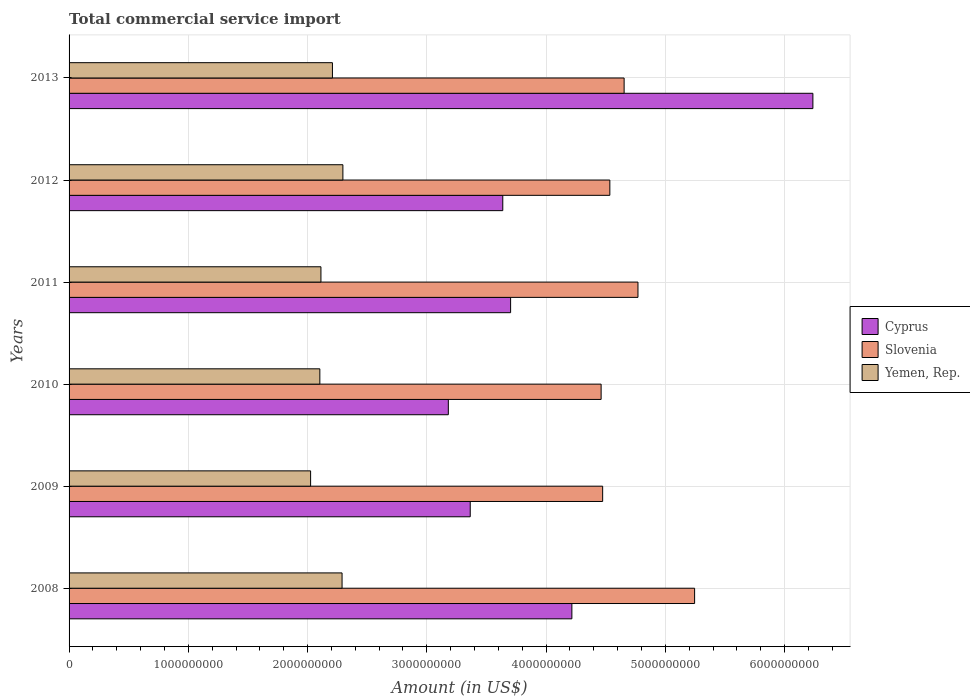How many groups of bars are there?
Give a very brief answer. 6. Are the number of bars per tick equal to the number of legend labels?
Offer a very short reply. Yes. Are the number of bars on each tick of the Y-axis equal?
Keep it short and to the point. Yes. How many bars are there on the 1st tick from the top?
Give a very brief answer. 3. How many bars are there on the 4th tick from the bottom?
Your response must be concise. 3. In how many cases, is the number of bars for a given year not equal to the number of legend labels?
Offer a terse response. 0. What is the total commercial service import in Slovenia in 2012?
Your answer should be compact. 4.53e+09. Across all years, what is the maximum total commercial service import in Cyprus?
Give a very brief answer. 6.24e+09. Across all years, what is the minimum total commercial service import in Slovenia?
Provide a short and direct response. 4.46e+09. In which year was the total commercial service import in Yemen, Rep. minimum?
Provide a short and direct response. 2009. What is the total total commercial service import in Yemen, Rep. in the graph?
Offer a terse response. 1.30e+1. What is the difference between the total commercial service import in Yemen, Rep. in 2010 and that in 2011?
Keep it short and to the point. -9.16e+06. What is the difference between the total commercial service import in Cyprus in 2009 and the total commercial service import in Slovenia in 2013?
Provide a succinct answer. -1.29e+09. What is the average total commercial service import in Cyprus per year?
Ensure brevity in your answer.  4.06e+09. In the year 2012, what is the difference between the total commercial service import in Cyprus and total commercial service import in Slovenia?
Ensure brevity in your answer.  -8.98e+08. What is the ratio of the total commercial service import in Slovenia in 2008 to that in 2010?
Offer a very short reply. 1.18. Is the total commercial service import in Slovenia in 2010 less than that in 2013?
Keep it short and to the point. Yes. Is the difference between the total commercial service import in Cyprus in 2011 and 2012 greater than the difference between the total commercial service import in Slovenia in 2011 and 2012?
Your response must be concise. No. What is the difference between the highest and the second highest total commercial service import in Slovenia?
Your answer should be very brief. 4.75e+08. What is the difference between the highest and the lowest total commercial service import in Cyprus?
Offer a terse response. 3.06e+09. What does the 3rd bar from the top in 2010 represents?
Keep it short and to the point. Cyprus. What does the 2nd bar from the bottom in 2009 represents?
Your answer should be very brief. Slovenia. Is it the case that in every year, the sum of the total commercial service import in Slovenia and total commercial service import in Yemen, Rep. is greater than the total commercial service import in Cyprus?
Offer a terse response. Yes. Are all the bars in the graph horizontal?
Provide a short and direct response. Yes. Are the values on the major ticks of X-axis written in scientific E-notation?
Offer a terse response. No. Where does the legend appear in the graph?
Your answer should be compact. Center right. What is the title of the graph?
Keep it short and to the point. Total commercial service import. What is the label or title of the X-axis?
Your answer should be very brief. Amount (in US$). What is the Amount (in US$) of Cyprus in 2008?
Provide a short and direct response. 4.22e+09. What is the Amount (in US$) in Slovenia in 2008?
Make the answer very short. 5.25e+09. What is the Amount (in US$) in Yemen, Rep. in 2008?
Provide a short and direct response. 2.29e+09. What is the Amount (in US$) in Cyprus in 2009?
Make the answer very short. 3.36e+09. What is the Amount (in US$) of Slovenia in 2009?
Offer a very short reply. 4.47e+09. What is the Amount (in US$) of Yemen, Rep. in 2009?
Provide a short and direct response. 2.03e+09. What is the Amount (in US$) of Cyprus in 2010?
Your response must be concise. 3.18e+09. What is the Amount (in US$) in Slovenia in 2010?
Your answer should be compact. 4.46e+09. What is the Amount (in US$) in Yemen, Rep. in 2010?
Provide a short and direct response. 2.10e+09. What is the Amount (in US$) of Cyprus in 2011?
Ensure brevity in your answer.  3.70e+09. What is the Amount (in US$) of Slovenia in 2011?
Provide a short and direct response. 4.77e+09. What is the Amount (in US$) of Yemen, Rep. in 2011?
Offer a very short reply. 2.11e+09. What is the Amount (in US$) of Cyprus in 2012?
Keep it short and to the point. 3.64e+09. What is the Amount (in US$) in Slovenia in 2012?
Your response must be concise. 4.53e+09. What is the Amount (in US$) of Yemen, Rep. in 2012?
Provide a short and direct response. 2.30e+09. What is the Amount (in US$) of Cyprus in 2013?
Your response must be concise. 6.24e+09. What is the Amount (in US$) in Slovenia in 2013?
Your response must be concise. 4.65e+09. What is the Amount (in US$) of Yemen, Rep. in 2013?
Provide a short and direct response. 2.21e+09. Across all years, what is the maximum Amount (in US$) in Cyprus?
Your answer should be very brief. 6.24e+09. Across all years, what is the maximum Amount (in US$) of Slovenia?
Give a very brief answer. 5.25e+09. Across all years, what is the maximum Amount (in US$) in Yemen, Rep.?
Make the answer very short. 2.30e+09. Across all years, what is the minimum Amount (in US$) of Cyprus?
Give a very brief answer. 3.18e+09. Across all years, what is the minimum Amount (in US$) in Slovenia?
Ensure brevity in your answer.  4.46e+09. Across all years, what is the minimum Amount (in US$) in Yemen, Rep.?
Ensure brevity in your answer.  2.03e+09. What is the total Amount (in US$) of Cyprus in the graph?
Offer a very short reply. 2.43e+1. What is the total Amount (in US$) of Slovenia in the graph?
Ensure brevity in your answer.  2.81e+1. What is the total Amount (in US$) in Yemen, Rep. in the graph?
Keep it short and to the point. 1.30e+1. What is the difference between the Amount (in US$) in Cyprus in 2008 and that in 2009?
Your answer should be compact. 8.52e+08. What is the difference between the Amount (in US$) of Slovenia in 2008 and that in 2009?
Ensure brevity in your answer.  7.71e+08. What is the difference between the Amount (in US$) of Yemen, Rep. in 2008 and that in 2009?
Ensure brevity in your answer.  2.64e+08. What is the difference between the Amount (in US$) in Cyprus in 2008 and that in 2010?
Ensure brevity in your answer.  1.04e+09. What is the difference between the Amount (in US$) in Slovenia in 2008 and that in 2010?
Your response must be concise. 7.84e+08. What is the difference between the Amount (in US$) of Yemen, Rep. in 2008 and that in 2010?
Your answer should be very brief. 1.86e+08. What is the difference between the Amount (in US$) in Cyprus in 2008 and that in 2011?
Provide a short and direct response. 5.14e+08. What is the difference between the Amount (in US$) of Slovenia in 2008 and that in 2011?
Keep it short and to the point. 4.75e+08. What is the difference between the Amount (in US$) in Yemen, Rep. in 2008 and that in 2011?
Offer a terse response. 1.77e+08. What is the difference between the Amount (in US$) in Cyprus in 2008 and that in 2012?
Your answer should be very brief. 5.79e+08. What is the difference between the Amount (in US$) of Slovenia in 2008 and that in 2012?
Provide a short and direct response. 7.11e+08. What is the difference between the Amount (in US$) of Yemen, Rep. in 2008 and that in 2012?
Offer a terse response. -6.96e+06. What is the difference between the Amount (in US$) in Cyprus in 2008 and that in 2013?
Keep it short and to the point. -2.02e+09. What is the difference between the Amount (in US$) in Slovenia in 2008 and that in 2013?
Ensure brevity in your answer.  5.91e+08. What is the difference between the Amount (in US$) of Yemen, Rep. in 2008 and that in 2013?
Offer a very short reply. 8.07e+07. What is the difference between the Amount (in US$) in Cyprus in 2009 and that in 2010?
Make the answer very short. 1.84e+08. What is the difference between the Amount (in US$) of Slovenia in 2009 and that in 2010?
Give a very brief answer. 1.28e+07. What is the difference between the Amount (in US$) of Yemen, Rep. in 2009 and that in 2010?
Offer a terse response. -7.75e+07. What is the difference between the Amount (in US$) in Cyprus in 2009 and that in 2011?
Ensure brevity in your answer.  -3.39e+08. What is the difference between the Amount (in US$) in Slovenia in 2009 and that in 2011?
Ensure brevity in your answer.  -2.96e+08. What is the difference between the Amount (in US$) in Yemen, Rep. in 2009 and that in 2011?
Provide a succinct answer. -8.66e+07. What is the difference between the Amount (in US$) in Cyprus in 2009 and that in 2012?
Provide a short and direct response. -2.73e+08. What is the difference between the Amount (in US$) in Slovenia in 2009 and that in 2012?
Your answer should be very brief. -6.03e+07. What is the difference between the Amount (in US$) of Yemen, Rep. in 2009 and that in 2012?
Your answer should be very brief. -2.71e+08. What is the difference between the Amount (in US$) of Cyprus in 2009 and that in 2013?
Ensure brevity in your answer.  -2.87e+09. What is the difference between the Amount (in US$) of Slovenia in 2009 and that in 2013?
Make the answer very short. -1.80e+08. What is the difference between the Amount (in US$) of Yemen, Rep. in 2009 and that in 2013?
Ensure brevity in your answer.  -1.83e+08. What is the difference between the Amount (in US$) in Cyprus in 2010 and that in 2011?
Offer a very short reply. -5.22e+08. What is the difference between the Amount (in US$) of Slovenia in 2010 and that in 2011?
Provide a succinct answer. -3.09e+08. What is the difference between the Amount (in US$) in Yemen, Rep. in 2010 and that in 2011?
Keep it short and to the point. -9.16e+06. What is the difference between the Amount (in US$) in Cyprus in 2010 and that in 2012?
Keep it short and to the point. -4.57e+08. What is the difference between the Amount (in US$) of Slovenia in 2010 and that in 2012?
Your answer should be very brief. -7.31e+07. What is the difference between the Amount (in US$) in Yemen, Rep. in 2010 and that in 2012?
Make the answer very short. -1.93e+08. What is the difference between the Amount (in US$) in Cyprus in 2010 and that in 2013?
Provide a short and direct response. -3.06e+09. What is the difference between the Amount (in US$) of Slovenia in 2010 and that in 2013?
Make the answer very short. -1.93e+08. What is the difference between the Amount (in US$) in Yemen, Rep. in 2010 and that in 2013?
Your response must be concise. -1.06e+08. What is the difference between the Amount (in US$) of Cyprus in 2011 and that in 2012?
Provide a succinct answer. 6.56e+07. What is the difference between the Amount (in US$) in Slovenia in 2011 and that in 2012?
Ensure brevity in your answer.  2.36e+08. What is the difference between the Amount (in US$) of Yemen, Rep. in 2011 and that in 2012?
Keep it short and to the point. -1.84e+08. What is the difference between the Amount (in US$) in Cyprus in 2011 and that in 2013?
Provide a short and direct response. -2.53e+09. What is the difference between the Amount (in US$) in Slovenia in 2011 and that in 2013?
Provide a succinct answer. 1.16e+08. What is the difference between the Amount (in US$) of Yemen, Rep. in 2011 and that in 2013?
Provide a short and direct response. -9.64e+07. What is the difference between the Amount (in US$) of Cyprus in 2012 and that in 2013?
Provide a short and direct response. -2.60e+09. What is the difference between the Amount (in US$) of Slovenia in 2012 and that in 2013?
Make the answer very short. -1.20e+08. What is the difference between the Amount (in US$) of Yemen, Rep. in 2012 and that in 2013?
Offer a terse response. 8.76e+07. What is the difference between the Amount (in US$) in Cyprus in 2008 and the Amount (in US$) in Slovenia in 2009?
Your answer should be compact. -2.58e+08. What is the difference between the Amount (in US$) in Cyprus in 2008 and the Amount (in US$) in Yemen, Rep. in 2009?
Your answer should be very brief. 2.19e+09. What is the difference between the Amount (in US$) of Slovenia in 2008 and the Amount (in US$) of Yemen, Rep. in 2009?
Provide a short and direct response. 3.22e+09. What is the difference between the Amount (in US$) in Cyprus in 2008 and the Amount (in US$) in Slovenia in 2010?
Your answer should be compact. -2.45e+08. What is the difference between the Amount (in US$) in Cyprus in 2008 and the Amount (in US$) in Yemen, Rep. in 2010?
Offer a terse response. 2.11e+09. What is the difference between the Amount (in US$) of Slovenia in 2008 and the Amount (in US$) of Yemen, Rep. in 2010?
Keep it short and to the point. 3.14e+09. What is the difference between the Amount (in US$) in Cyprus in 2008 and the Amount (in US$) in Slovenia in 2011?
Ensure brevity in your answer.  -5.54e+08. What is the difference between the Amount (in US$) in Cyprus in 2008 and the Amount (in US$) in Yemen, Rep. in 2011?
Ensure brevity in your answer.  2.10e+09. What is the difference between the Amount (in US$) in Slovenia in 2008 and the Amount (in US$) in Yemen, Rep. in 2011?
Your answer should be compact. 3.13e+09. What is the difference between the Amount (in US$) of Cyprus in 2008 and the Amount (in US$) of Slovenia in 2012?
Provide a succinct answer. -3.18e+08. What is the difference between the Amount (in US$) in Cyprus in 2008 and the Amount (in US$) in Yemen, Rep. in 2012?
Ensure brevity in your answer.  1.92e+09. What is the difference between the Amount (in US$) in Slovenia in 2008 and the Amount (in US$) in Yemen, Rep. in 2012?
Provide a succinct answer. 2.95e+09. What is the difference between the Amount (in US$) in Cyprus in 2008 and the Amount (in US$) in Slovenia in 2013?
Keep it short and to the point. -4.38e+08. What is the difference between the Amount (in US$) in Cyprus in 2008 and the Amount (in US$) in Yemen, Rep. in 2013?
Give a very brief answer. 2.01e+09. What is the difference between the Amount (in US$) in Slovenia in 2008 and the Amount (in US$) in Yemen, Rep. in 2013?
Offer a terse response. 3.04e+09. What is the difference between the Amount (in US$) in Cyprus in 2009 and the Amount (in US$) in Slovenia in 2010?
Offer a terse response. -1.10e+09. What is the difference between the Amount (in US$) in Cyprus in 2009 and the Amount (in US$) in Yemen, Rep. in 2010?
Your response must be concise. 1.26e+09. What is the difference between the Amount (in US$) of Slovenia in 2009 and the Amount (in US$) of Yemen, Rep. in 2010?
Offer a terse response. 2.37e+09. What is the difference between the Amount (in US$) in Cyprus in 2009 and the Amount (in US$) in Slovenia in 2011?
Ensure brevity in your answer.  -1.41e+09. What is the difference between the Amount (in US$) of Cyprus in 2009 and the Amount (in US$) of Yemen, Rep. in 2011?
Your response must be concise. 1.25e+09. What is the difference between the Amount (in US$) of Slovenia in 2009 and the Amount (in US$) of Yemen, Rep. in 2011?
Your response must be concise. 2.36e+09. What is the difference between the Amount (in US$) in Cyprus in 2009 and the Amount (in US$) in Slovenia in 2012?
Provide a short and direct response. -1.17e+09. What is the difference between the Amount (in US$) in Cyprus in 2009 and the Amount (in US$) in Yemen, Rep. in 2012?
Your answer should be very brief. 1.07e+09. What is the difference between the Amount (in US$) of Slovenia in 2009 and the Amount (in US$) of Yemen, Rep. in 2012?
Offer a very short reply. 2.18e+09. What is the difference between the Amount (in US$) in Cyprus in 2009 and the Amount (in US$) in Slovenia in 2013?
Give a very brief answer. -1.29e+09. What is the difference between the Amount (in US$) in Cyprus in 2009 and the Amount (in US$) in Yemen, Rep. in 2013?
Ensure brevity in your answer.  1.16e+09. What is the difference between the Amount (in US$) in Slovenia in 2009 and the Amount (in US$) in Yemen, Rep. in 2013?
Ensure brevity in your answer.  2.27e+09. What is the difference between the Amount (in US$) of Cyprus in 2010 and the Amount (in US$) of Slovenia in 2011?
Ensure brevity in your answer.  -1.59e+09. What is the difference between the Amount (in US$) of Cyprus in 2010 and the Amount (in US$) of Yemen, Rep. in 2011?
Provide a succinct answer. 1.07e+09. What is the difference between the Amount (in US$) in Slovenia in 2010 and the Amount (in US$) in Yemen, Rep. in 2011?
Your response must be concise. 2.35e+09. What is the difference between the Amount (in US$) of Cyprus in 2010 and the Amount (in US$) of Slovenia in 2012?
Provide a short and direct response. -1.35e+09. What is the difference between the Amount (in US$) of Cyprus in 2010 and the Amount (in US$) of Yemen, Rep. in 2012?
Make the answer very short. 8.84e+08. What is the difference between the Amount (in US$) in Slovenia in 2010 and the Amount (in US$) in Yemen, Rep. in 2012?
Offer a terse response. 2.17e+09. What is the difference between the Amount (in US$) of Cyprus in 2010 and the Amount (in US$) of Slovenia in 2013?
Your answer should be compact. -1.47e+09. What is the difference between the Amount (in US$) of Cyprus in 2010 and the Amount (in US$) of Yemen, Rep. in 2013?
Your response must be concise. 9.72e+08. What is the difference between the Amount (in US$) of Slovenia in 2010 and the Amount (in US$) of Yemen, Rep. in 2013?
Give a very brief answer. 2.25e+09. What is the difference between the Amount (in US$) in Cyprus in 2011 and the Amount (in US$) in Slovenia in 2012?
Provide a short and direct response. -8.32e+08. What is the difference between the Amount (in US$) in Cyprus in 2011 and the Amount (in US$) in Yemen, Rep. in 2012?
Keep it short and to the point. 1.41e+09. What is the difference between the Amount (in US$) of Slovenia in 2011 and the Amount (in US$) of Yemen, Rep. in 2012?
Your answer should be very brief. 2.47e+09. What is the difference between the Amount (in US$) of Cyprus in 2011 and the Amount (in US$) of Slovenia in 2013?
Offer a terse response. -9.52e+08. What is the difference between the Amount (in US$) of Cyprus in 2011 and the Amount (in US$) of Yemen, Rep. in 2013?
Your answer should be compact. 1.49e+09. What is the difference between the Amount (in US$) in Slovenia in 2011 and the Amount (in US$) in Yemen, Rep. in 2013?
Keep it short and to the point. 2.56e+09. What is the difference between the Amount (in US$) of Cyprus in 2012 and the Amount (in US$) of Slovenia in 2013?
Your answer should be compact. -1.02e+09. What is the difference between the Amount (in US$) of Cyprus in 2012 and the Amount (in US$) of Yemen, Rep. in 2013?
Make the answer very short. 1.43e+09. What is the difference between the Amount (in US$) of Slovenia in 2012 and the Amount (in US$) of Yemen, Rep. in 2013?
Provide a short and direct response. 2.33e+09. What is the average Amount (in US$) in Cyprus per year?
Provide a short and direct response. 4.06e+09. What is the average Amount (in US$) in Slovenia per year?
Offer a terse response. 4.69e+09. What is the average Amount (in US$) of Yemen, Rep. per year?
Keep it short and to the point. 2.17e+09. In the year 2008, what is the difference between the Amount (in US$) in Cyprus and Amount (in US$) in Slovenia?
Offer a very short reply. -1.03e+09. In the year 2008, what is the difference between the Amount (in US$) in Cyprus and Amount (in US$) in Yemen, Rep.?
Offer a terse response. 1.93e+09. In the year 2008, what is the difference between the Amount (in US$) in Slovenia and Amount (in US$) in Yemen, Rep.?
Your answer should be very brief. 2.96e+09. In the year 2009, what is the difference between the Amount (in US$) in Cyprus and Amount (in US$) in Slovenia?
Offer a very short reply. -1.11e+09. In the year 2009, what is the difference between the Amount (in US$) of Cyprus and Amount (in US$) of Yemen, Rep.?
Keep it short and to the point. 1.34e+09. In the year 2009, what is the difference between the Amount (in US$) in Slovenia and Amount (in US$) in Yemen, Rep.?
Your answer should be compact. 2.45e+09. In the year 2010, what is the difference between the Amount (in US$) in Cyprus and Amount (in US$) in Slovenia?
Provide a succinct answer. -1.28e+09. In the year 2010, what is the difference between the Amount (in US$) in Cyprus and Amount (in US$) in Yemen, Rep.?
Ensure brevity in your answer.  1.08e+09. In the year 2010, what is the difference between the Amount (in US$) in Slovenia and Amount (in US$) in Yemen, Rep.?
Your answer should be compact. 2.36e+09. In the year 2011, what is the difference between the Amount (in US$) in Cyprus and Amount (in US$) in Slovenia?
Ensure brevity in your answer.  -1.07e+09. In the year 2011, what is the difference between the Amount (in US$) of Cyprus and Amount (in US$) of Yemen, Rep.?
Make the answer very short. 1.59e+09. In the year 2011, what is the difference between the Amount (in US$) of Slovenia and Amount (in US$) of Yemen, Rep.?
Offer a very short reply. 2.66e+09. In the year 2012, what is the difference between the Amount (in US$) of Cyprus and Amount (in US$) of Slovenia?
Your response must be concise. -8.98e+08. In the year 2012, what is the difference between the Amount (in US$) of Cyprus and Amount (in US$) of Yemen, Rep.?
Offer a terse response. 1.34e+09. In the year 2012, what is the difference between the Amount (in US$) of Slovenia and Amount (in US$) of Yemen, Rep.?
Provide a succinct answer. 2.24e+09. In the year 2013, what is the difference between the Amount (in US$) in Cyprus and Amount (in US$) in Slovenia?
Offer a terse response. 1.58e+09. In the year 2013, what is the difference between the Amount (in US$) in Cyprus and Amount (in US$) in Yemen, Rep.?
Your answer should be compact. 4.03e+09. In the year 2013, what is the difference between the Amount (in US$) in Slovenia and Amount (in US$) in Yemen, Rep.?
Give a very brief answer. 2.45e+09. What is the ratio of the Amount (in US$) in Cyprus in 2008 to that in 2009?
Offer a very short reply. 1.25. What is the ratio of the Amount (in US$) of Slovenia in 2008 to that in 2009?
Your answer should be compact. 1.17. What is the ratio of the Amount (in US$) of Yemen, Rep. in 2008 to that in 2009?
Your answer should be very brief. 1.13. What is the ratio of the Amount (in US$) of Cyprus in 2008 to that in 2010?
Your response must be concise. 1.33. What is the ratio of the Amount (in US$) in Slovenia in 2008 to that in 2010?
Offer a very short reply. 1.18. What is the ratio of the Amount (in US$) of Yemen, Rep. in 2008 to that in 2010?
Your response must be concise. 1.09. What is the ratio of the Amount (in US$) in Cyprus in 2008 to that in 2011?
Keep it short and to the point. 1.14. What is the ratio of the Amount (in US$) in Slovenia in 2008 to that in 2011?
Your answer should be compact. 1.1. What is the ratio of the Amount (in US$) of Yemen, Rep. in 2008 to that in 2011?
Offer a terse response. 1.08. What is the ratio of the Amount (in US$) in Cyprus in 2008 to that in 2012?
Provide a succinct answer. 1.16. What is the ratio of the Amount (in US$) in Slovenia in 2008 to that in 2012?
Your response must be concise. 1.16. What is the ratio of the Amount (in US$) in Cyprus in 2008 to that in 2013?
Keep it short and to the point. 0.68. What is the ratio of the Amount (in US$) of Slovenia in 2008 to that in 2013?
Your answer should be very brief. 1.13. What is the ratio of the Amount (in US$) of Yemen, Rep. in 2008 to that in 2013?
Give a very brief answer. 1.04. What is the ratio of the Amount (in US$) of Cyprus in 2009 to that in 2010?
Offer a very short reply. 1.06. What is the ratio of the Amount (in US$) in Slovenia in 2009 to that in 2010?
Provide a succinct answer. 1. What is the ratio of the Amount (in US$) in Yemen, Rep. in 2009 to that in 2010?
Your response must be concise. 0.96. What is the ratio of the Amount (in US$) in Cyprus in 2009 to that in 2011?
Keep it short and to the point. 0.91. What is the ratio of the Amount (in US$) of Slovenia in 2009 to that in 2011?
Offer a very short reply. 0.94. What is the ratio of the Amount (in US$) in Cyprus in 2009 to that in 2012?
Your response must be concise. 0.93. What is the ratio of the Amount (in US$) of Slovenia in 2009 to that in 2012?
Your answer should be very brief. 0.99. What is the ratio of the Amount (in US$) of Yemen, Rep. in 2009 to that in 2012?
Provide a succinct answer. 0.88. What is the ratio of the Amount (in US$) in Cyprus in 2009 to that in 2013?
Your answer should be compact. 0.54. What is the ratio of the Amount (in US$) of Slovenia in 2009 to that in 2013?
Your response must be concise. 0.96. What is the ratio of the Amount (in US$) of Yemen, Rep. in 2009 to that in 2013?
Ensure brevity in your answer.  0.92. What is the ratio of the Amount (in US$) in Cyprus in 2010 to that in 2011?
Your answer should be very brief. 0.86. What is the ratio of the Amount (in US$) of Slovenia in 2010 to that in 2011?
Provide a succinct answer. 0.94. What is the ratio of the Amount (in US$) in Cyprus in 2010 to that in 2012?
Offer a terse response. 0.87. What is the ratio of the Amount (in US$) of Slovenia in 2010 to that in 2012?
Give a very brief answer. 0.98. What is the ratio of the Amount (in US$) in Yemen, Rep. in 2010 to that in 2012?
Offer a terse response. 0.92. What is the ratio of the Amount (in US$) in Cyprus in 2010 to that in 2013?
Provide a short and direct response. 0.51. What is the ratio of the Amount (in US$) in Slovenia in 2010 to that in 2013?
Offer a terse response. 0.96. What is the ratio of the Amount (in US$) of Yemen, Rep. in 2010 to that in 2013?
Your answer should be very brief. 0.95. What is the ratio of the Amount (in US$) of Slovenia in 2011 to that in 2012?
Make the answer very short. 1.05. What is the ratio of the Amount (in US$) in Yemen, Rep. in 2011 to that in 2012?
Your response must be concise. 0.92. What is the ratio of the Amount (in US$) of Cyprus in 2011 to that in 2013?
Offer a terse response. 0.59. What is the ratio of the Amount (in US$) in Slovenia in 2011 to that in 2013?
Give a very brief answer. 1.02. What is the ratio of the Amount (in US$) in Yemen, Rep. in 2011 to that in 2013?
Your response must be concise. 0.96. What is the ratio of the Amount (in US$) of Cyprus in 2012 to that in 2013?
Ensure brevity in your answer.  0.58. What is the ratio of the Amount (in US$) of Slovenia in 2012 to that in 2013?
Ensure brevity in your answer.  0.97. What is the ratio of the Amount (in US$) in Yemen, Rep. in 2012 to that in 2013?
Your answer should be very brief. 1.04. What is the difference between the highest and the second highest Amount (in US$) of Cyprus?
Offer a terse response. 2.02e+09. What is the difference between the highest and the second highest Amount (in US$) of Slovenia?
Your answer should be compact. 4.75e+08. What is the difference between the highest and the second highest Amount (in US$) in Yemen, Rep.?
Give a very brief answer. 6.96e+06. What is the difference between the highest and the lowest Amount (in US$) in Cyprus?
Make the answer very short. 3.06e+09. What is the difference between the highest and the lowest Amount (in US$) in Slovenia?
Give a very brief answer. 7.84e+08. What is the difference between the highest and the lowest Amount (in US$) of Yemen, Rep.?
Offer a terse response. 2.71e+08. 